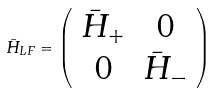Convert formula to latex. <formula><loc_0><loc_0><loc_500><loc_500>\bar { H } _ { L F } = \left ( \begin{array} { c c } \bar { H } _ { + } & 0 \\ 0 & \bar { H } _ { - } \\ \end{array} \right )</formula> 